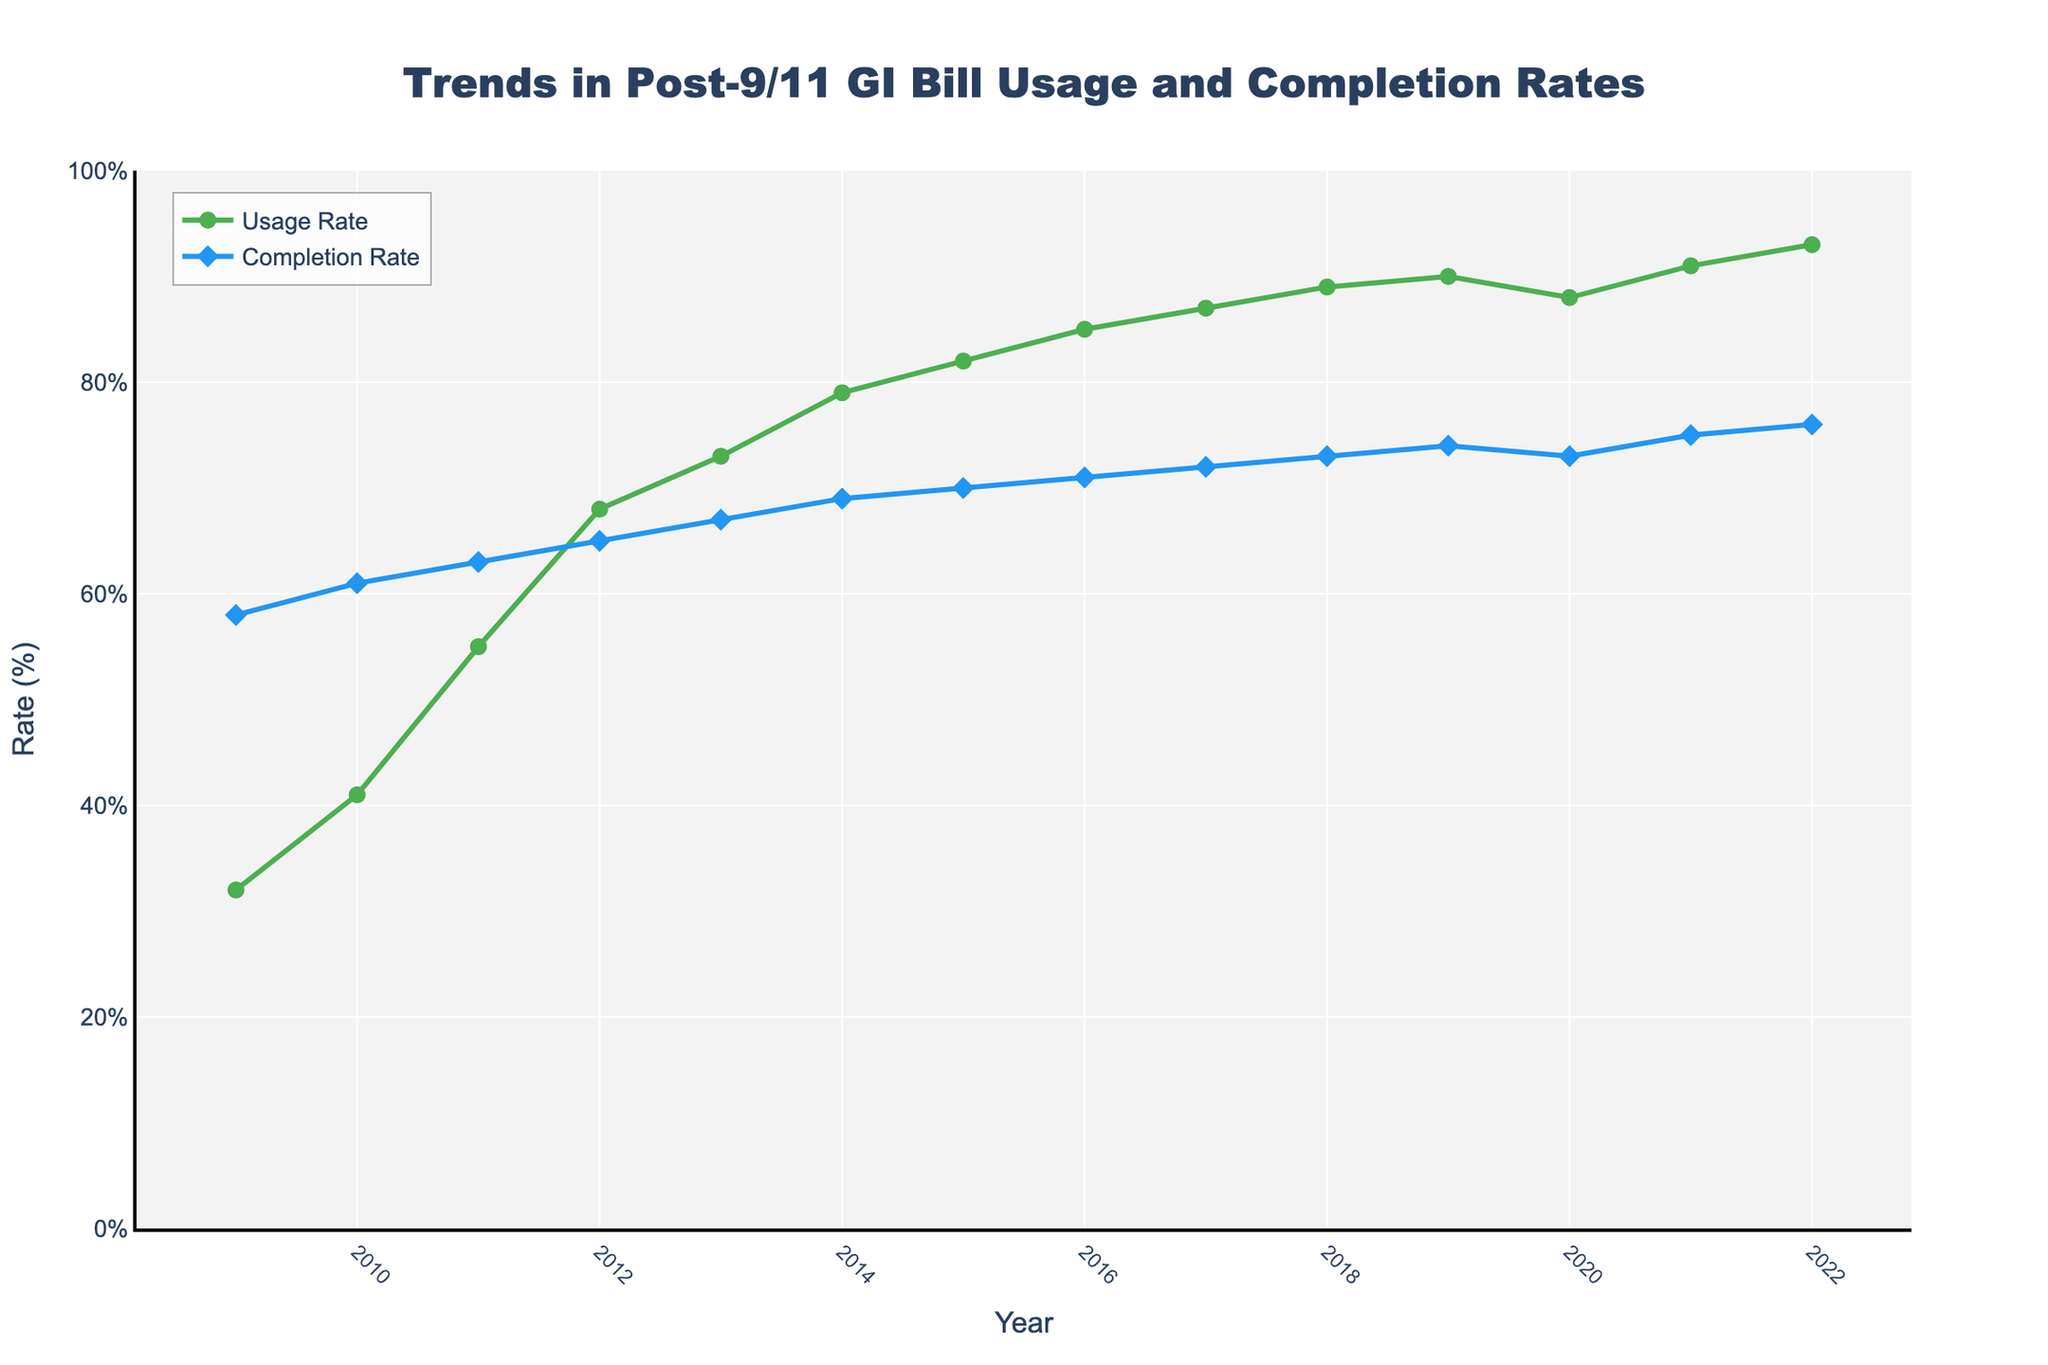What year had the highest usage rate? The figure shows both usage and completion rates over the years. Check the line labeled 'Usage Rate' and find the highest point. The highest usage rate is observed in the year 2022.
Answer: 2022 What is the difference in completion rates between 2009 and 2022? Identify the completion rates in 2009 and 2022 from the figure. The completion rate in 2009 is 58%, and in 2022 it is 76%. The difference is calculated by subtracting 58 from 76.
Answer: 18% In which year did the completion rate first reach 70%? Look at the 'Completion Rate' line and find the first year where the value is 70% or higher. In this case, the figure shows that it occurred in 2015.
Answer: 2015 How did the usage rate change from 2018 to 2019? Observe the 'Usage Rate' values for 2018 and 2019. The rate in 2018 is 89%, and in 2019 it is 90%. The change is calculated by subtracting 89 from 90.
Answer: Increased by 1% What is the average completion rate over the entire period? Sum up all completion rates from 2009 to 2022 and divide by the number of years (14). The sum is 58+61+63+65+67+69+70+71+72+73+74+73+75+76, which equals 967. Divide 967 by 14 to get the average.
Answer: 69.1% Which rate increased at a faster pace from 2009 to 2012, usage or completion rate? Calculate the increase for both rates over the specified period. The usage rate increased from 32% to 68% (68-32=36%), and the completion rate increased from 58% to 65% (65-58=7%). Compare the two increments.
Answer: Usage rate In which year is the gap between usage rate and completion rate the smallest? Calculate the difference between the two rates for each year and identify the smallest value. By inspecting the figure, it appears the smallest gap is in 2009, where the difference is 26%.
Answer: 2009 What is the trend in usage rates between 2019 and 2021? Observe the usage rate values for 2019, 2020, and 2021. It starts at 90% in 2019, drops slightly to 88% in 2020, and then rises to 91% in 2021, indicating a minor fluctuation.
Answer: Fluctuating What color represents the line showing completion rates? Look at the visual attributes of the figure, noting the color used for the completion rate line. It is represented by a blue line.
Answer: Blue Which year experienced a decline in completion rate compared to the previous year? Observe the 'Completion Rate' line and find the year where the rate drops compared to the previous year. According to the figure, this drop happens from 2019 to 2020.
Answer: 2020 